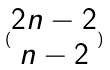<formula> <loc_0><loc_0><loc_500><loc_500>( \begin{matrix} 2 n - 2 \\ n - 2 \end{matrix} )</formula> 